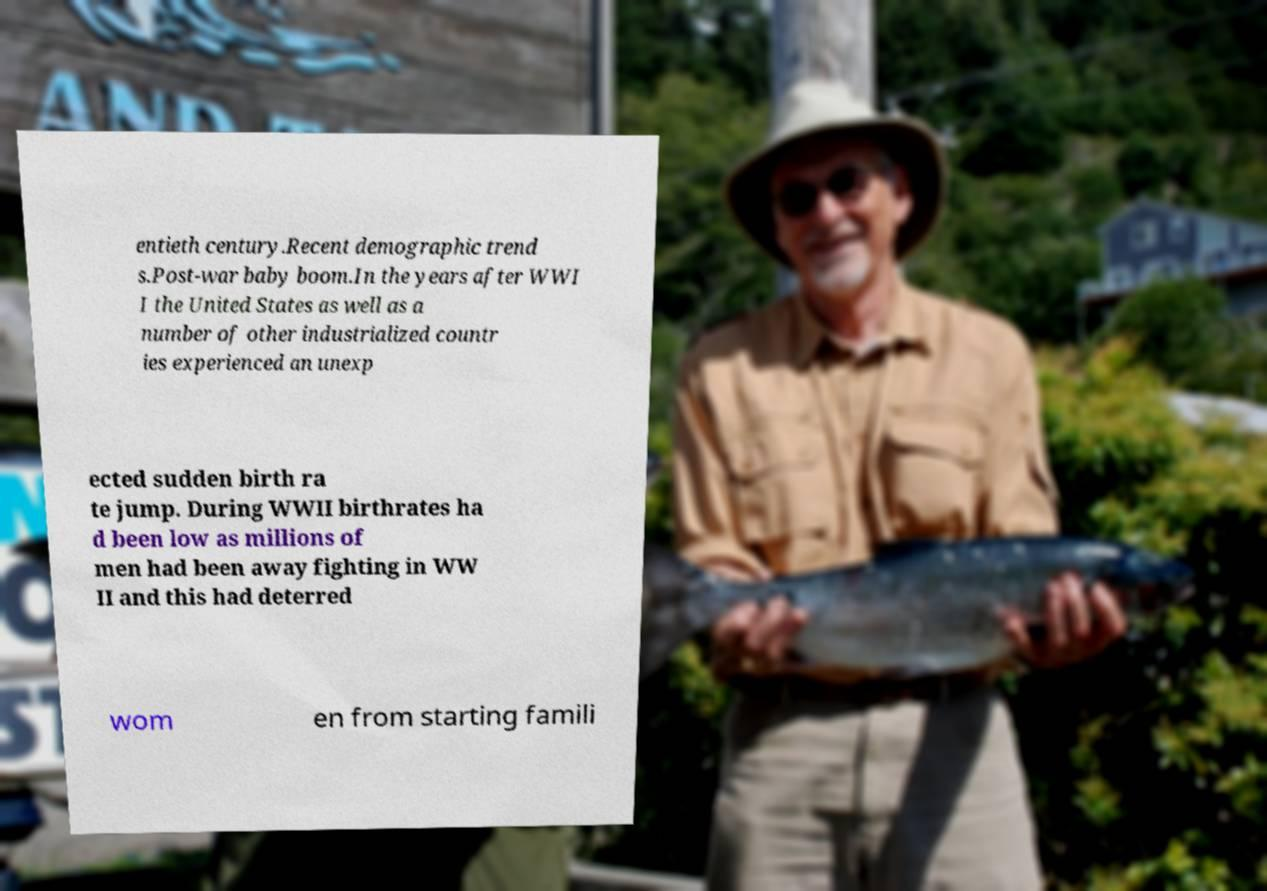There's text embedded in this image that I need extracted. Can you transcribe it verbatim? entieth century.Recent demographic trend s.Post-war baby boom.In the years after WWI I the United States as well as a number of other industrialized countr ies experienced an unexp ected sudden birth ra te jump. During WWII birthrates ha d been low as millions of men had been away fighting in WW II and this had deterred wom en from starting famili 